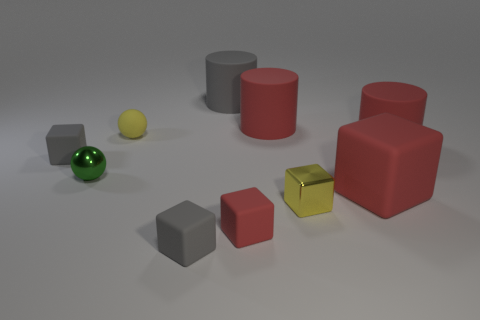Subtract 2 cubes. How many cubes are left? 3 Subtract all yellow blocks. How many blocks are left? 4 Subtract all large red cubes. How many cubes are left? 4 Subtract all purple cubes. Subtract all red balls. How many cubes are left? 5 Subtract all spheres. How many objects are left? 8 Subtract 0 blue spheres. How many objects are left? 10 Subtract all rubber cubes. Subtract all gray things. How many objects are left? 3 Add 9 yellow shiny things. How many yellow shiny things are left? 10 Add 6 small matte spheres. How many small matte spheres exist? 7 